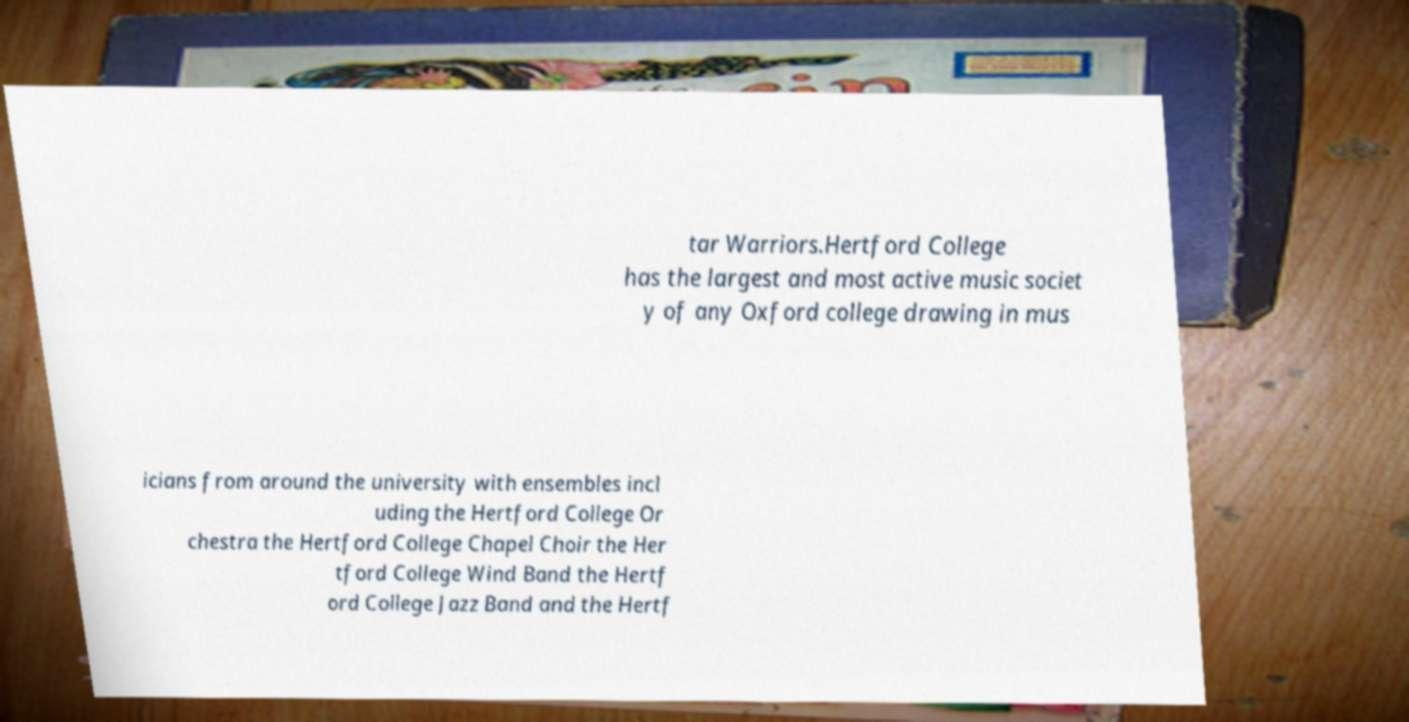Can you accurately transcribe the text from the provided image for me? tar Warriors.Hertford College has the largest and most active music societ y of any Oxford college drawing in mus icians from around the university with ensembles incl uding the Hertford College Or chestra the Hertford College Chapel Choir the Her tford College Wind Band the Hertf ord College Jazz Band and the Hertf 